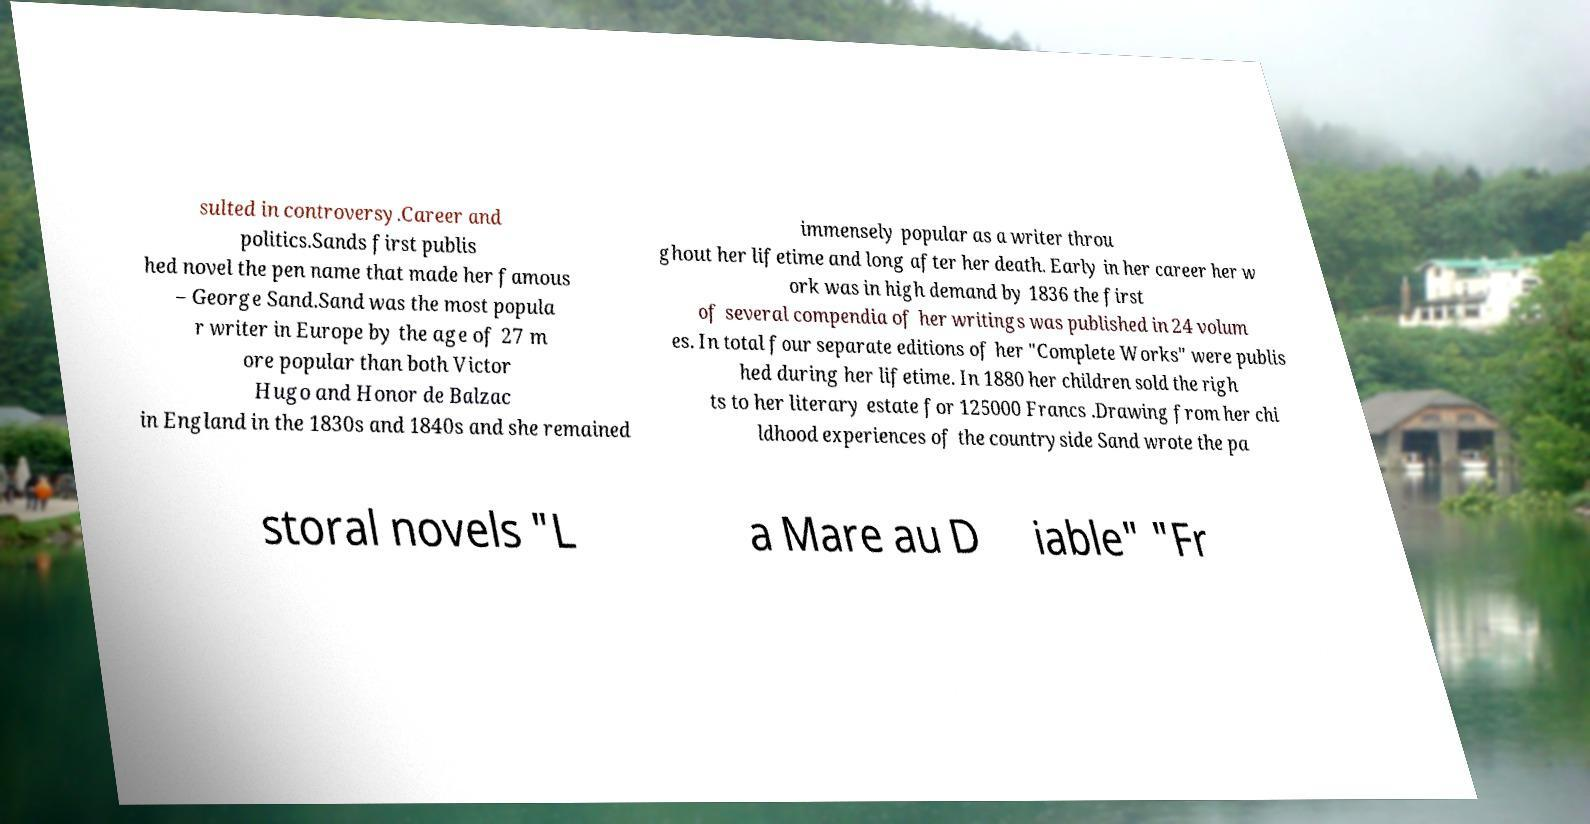I need the written content from this picture converted into text. Can you do that? sulted in controversy.Career and politics.Sands first publis hed novel the pen name that made her famous – George Sand.Sand was the most popula r writer in Europe by the age of 27 m ore popular than both Victor Hugo and Honor de Balzac in England in the 1830s and 1840s and she remained immensely popular as a writer throu ghout her lifetime and long after her death. Early in her career her w ork was in high demand by 1836 the first of several compendia of her writings was published in 24 volum es. In total four separate editions of her "Complete Works" were publis hed during her lifetime. In 1880 her children sold the righ ts to her literary estate for 125000 Francs .Drawing from her chi ldhood experiences of the countryside Sand wrote the pa storal novels "L a Mare au D iable" "Fr 